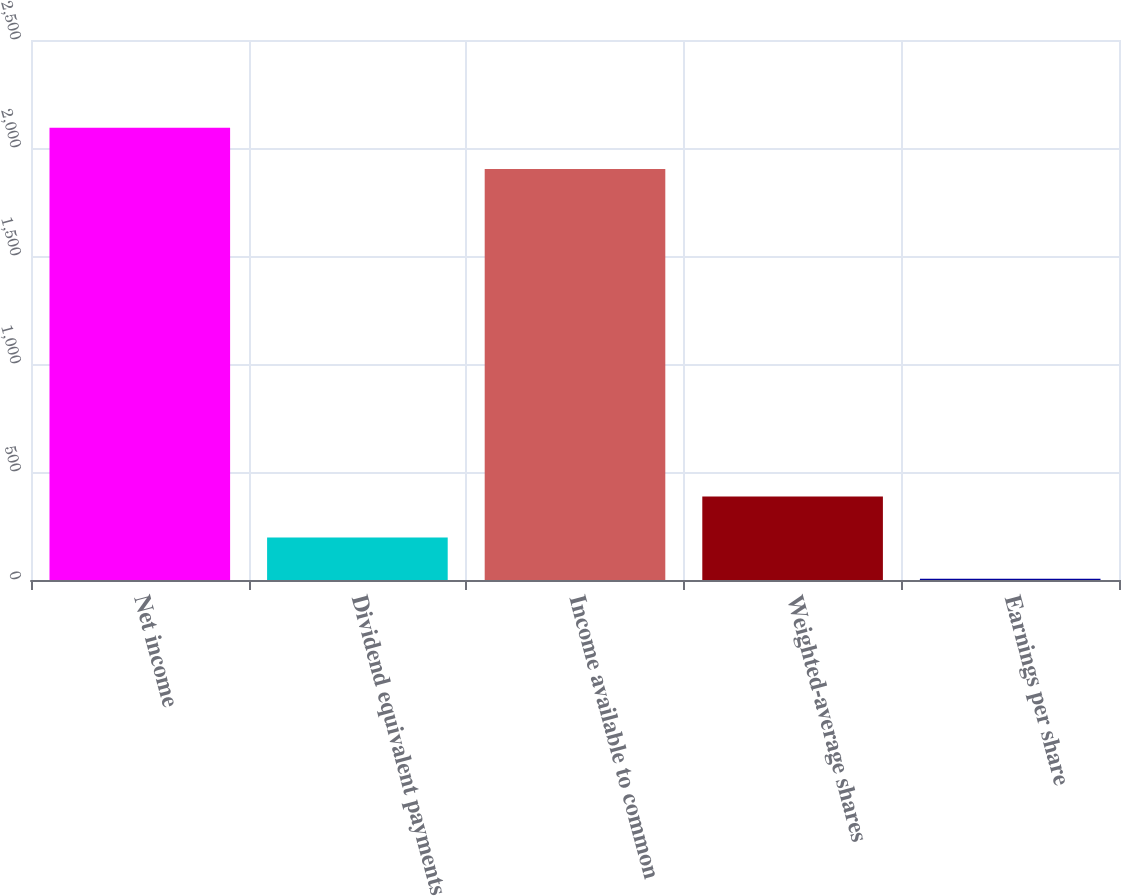Convert chart to OTSL. <chart><loc_0><loc_0><loc_500><loc_500><bar_chart><fcel>Net income<fcel>Dividend equivalent payments<fcel>Income available to common<fcel>Weighted-average shares<fcel>Earnings per share<nl><fcel>2093.39<fcel>196.49<fcel>1903<fcel>386.88<fcel>6.1<nl></chart> 